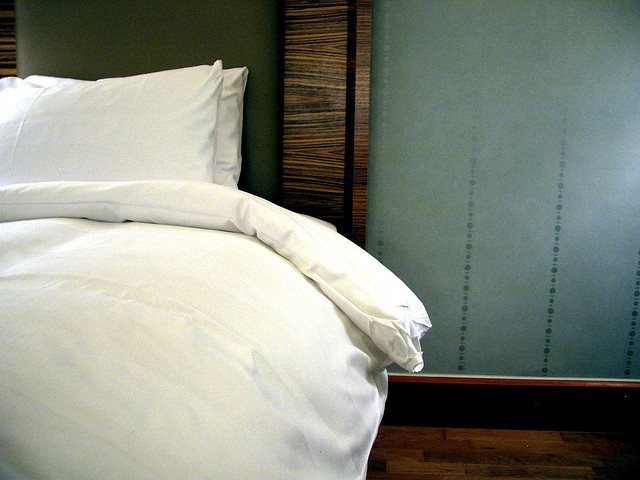Describe the objects in this image and their specific colors. I can see a bed in black, ivory, beige, and darkgray tones in this image. 